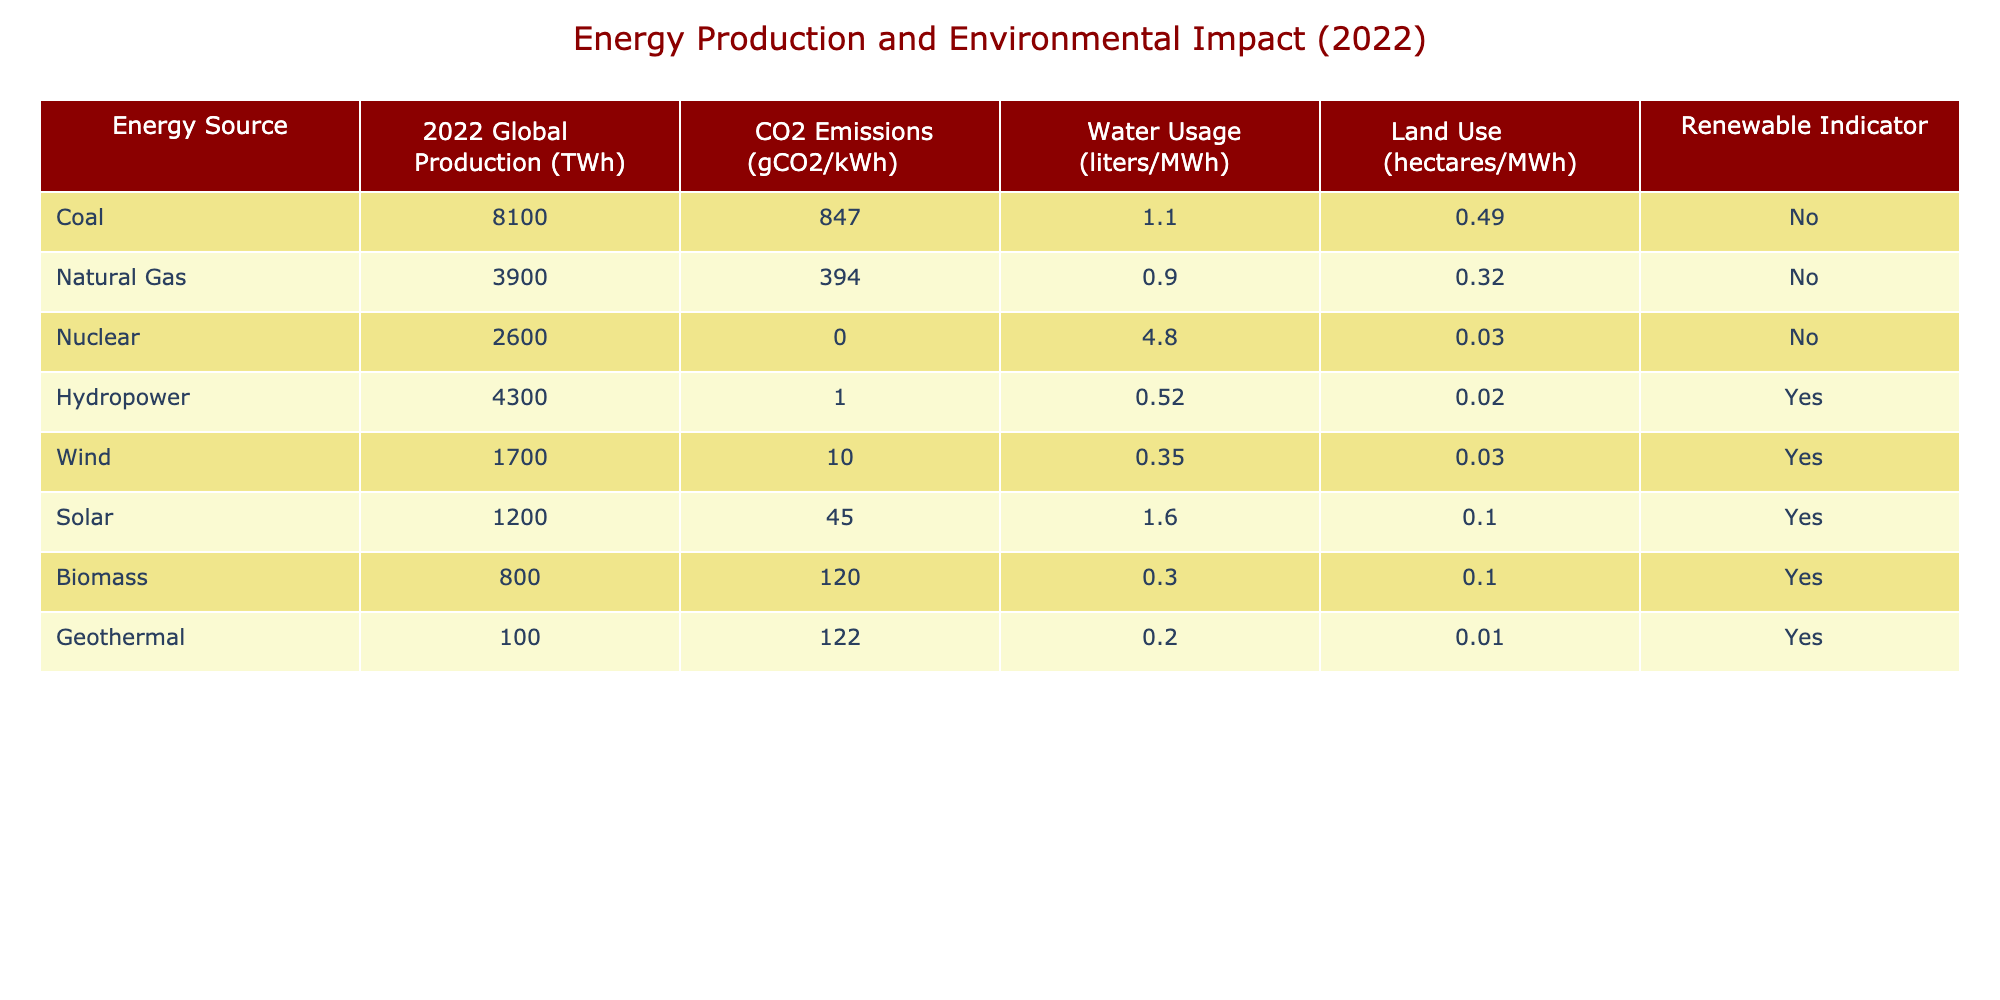What is the global energy production from coal in 2022? The table states that the global production of coal in 2022 is 8100 TWh.
Answer: 8100 TWh Which energy source has the highest CO2 emissions per kilowatt-hour? By examining the CO2 emissions figures, coal has 847 gCO2/kWh, which is higher than all other sources listed.
Answer: Coal Does nuclear energy have any CO2 emissions associated with it? The table shows that nuclear energy has 0 gCO2/kWh, indicating it does not produce CO2 emissions.
Answer: No What is the total water usage (in liters) for all renewable energy sources? The water usage for renewable sources is: Hydropower (0.52) + Wind (0.35) + Solar (1.60) + Biomass (0.30) + Geothermal (0.20) = 0.52 + 0.35 + 1.60 + 0.30 + 0.20 = 3.97 liters/MWh.
Answer: 3.97 liters/MWh How much land use does wind energy require per megawatt-hour? The table provides that wind energy requires 0.03 hectares/MWh for land use.
Answer: 0.03 hectares/MWh Which renewable energy source has the lowest CO2 emissions, and what is that value? By comparing the CO2 emissions of renewable sources, hydropower has 1 gCO2/kWh, which is the lowest among them.
Answer: Hydropower, 1 gCO2/kWh If we consider biomass and geothermal together, what is the average water usage for these two energy sources? First, we find the water usage values: Biomass uses 0.30 liters/MWh and Geothermal uses 0.20 liters/MWh. Adding them gives 0.30 + 0.20 = 0.50 liters/MWh. Dividing this by 2 for the average results in 0.50 / 2 = 0.25 liters/MWh.
Answer: 0.25 liters/MWh What percentage of the total energy production in 2022 comes from natural gas? The total global energy production from all sources is 8100 (coal) + 3900 (natural gas) + 2600 (nuclear) + 4300 (hydropower) + 1700 (wind) + 1200 (solar) + 800 (biomass) + 100 (geothermal) = 20300 TWh. Natural gas production is 3900 TWh. Thus, the percentage is (3900 / 20300) * 100 ≈ 19.21%.
Answer: Approximately 19.21% Is solar energy a renewable source? The table lists solar energy with a "Yes" under the renewable indicator, confirming that it is a renewable source.
Answer: Yes 